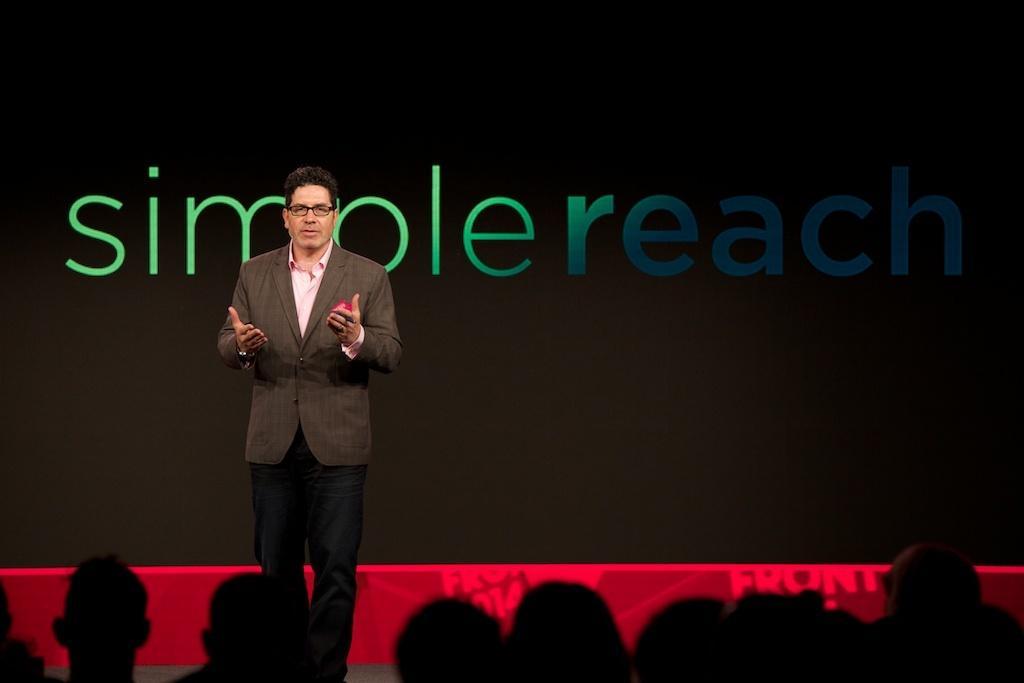How would you summarize this image in a sentence or two? In this image I can see person is standing and wearing brown coat and pant. In front I can see few people. Back Side I can see black color banner and simple reach is written on it. 